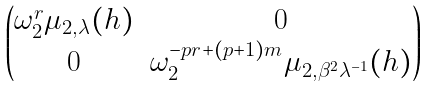<formula> <loc_0><loc_0><loc_500><loc_500>\begin{pmatrix} \omega _ { 2 } ^ { r } \mu _ { 2 , \lambda } ( h ) & 0 \\ 0 & \omega _ { 2 } ^ { - p r + ( p + 1 ) m } \mu _ { 2 , \beta ^ { 2 } \lambda ^ { - 1 } } ( h ) \end{pmatrix}</formula> 